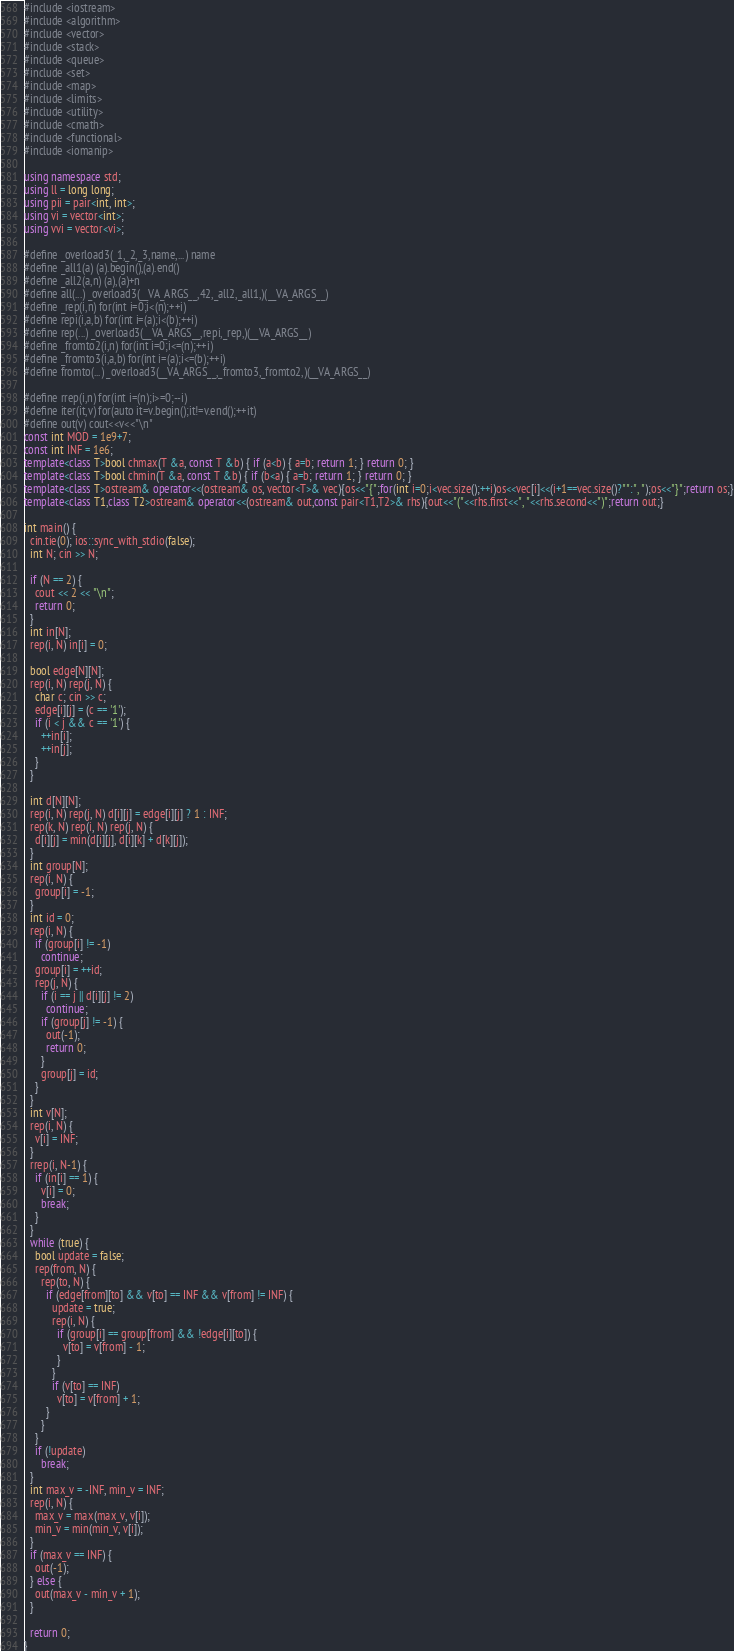<code> <loc_0><loc_0><loc_500><loc_500><_C++_>#include <iostream>
#include <algorithm>
#include <vector>
#include <stack>
#include <queue>
#include <set>
#include <map>
#include <limits>
#include <utility>
#include <cmath>
#include <functional>
#include <iomanip>

using namespace std;
using ll = long long;
using pii = pair<int, int>;
using vi = vector<int>;
using vvi = vector<vi>;

#define _overload3(_1,_2,_3,name,...) name
#define _all1(a) (a).begin(),(a).end()
#define _all2(a,n) (a),(a)+n
#define all(...) _overload3(__VA_ARGS__,42,_all2,_all1,)(__VA_ARGS__)
#define _rep(i,n) for(int i=0;i<(n);++i)
#define repi(i,a,b) for(int i=(a);i<(b);++i)
#define rep(...) _overload3(__VA_ARGS__,repi,_rep,)(__VA_ARGS__)
#define _fromto2(i,n) for(int i=0;i<=(n);++i)
#define _fromto3(i,a,b) for(int i=(a);i<=(b);++i)
#define fromto(...) _overload3(__VA_ARGS__,_fromto3,_fromto2,)(__VA_ARGS__)

#define rrep(i,n) for(int i=(n);i>=0;--i)
#define iter(it,v) for(auto it=v.begin();it!=v.end();++it)
#define out(v) cout<<v<<"\n"
const int MOD = 1e9+7;
const int INF = 1e6;
template<class T>bool chmax(T &a, const T &b) { if (a<b) { a=b; return 1; } return 0; }
template<class T>bool chmin(T &a, const T &b) { if (b<a) { a=b; return 1; } return 0; }
template<class T>ostream& operator<<(ostream& os, vector<T>& vec){os<<"{";for(int i=0;i<vec.size();++i)os<<vec[i]<<(i+1==vec.size()?"":", ");os<<"}";return os;}
template<class T1,class T2>ostream& operator<<(ostream& out,const pair<T1,T2>& rhs){out<<"("<<rhs.first<<", "<<rhs.second<<")";return out;}

int main() {
  cin.tie(0); ios::sync_with_stdio(false);
  int N; cin >> N;

  if (N == 2) {
    cout << 2 << "\n";
    return 0;
  }
  int in[N];
  rep(i, N) in[i] = 0;

  bool edge[N][N];
  rep(i, N) rep(j, N) {
    char c; cin >> c;
    edge[i][j] = (c == '1');
    if (i < j && c == '1') {
      ++in[i];
      ++in[j];
    }
  }

  int d[N][N];
  rep(i, N) rep(j, N) d[i][j] = edge[i][j] ? 1 : INF;
  rep(k, N) rep(i, N) rep(j, N) {
    d[i][j] = min(d[i][j], d[i][k] + d[k][j]);
  }
  int group[N];
  rep(i, N) {
    group[i] = -1;
  }
  int id = 0;
  rep(i, N) {
    if (group[i] != -1)
      continue;
    group[i] = ++id;
    rep(j, N) {
      if (i == j || d[i][j] != 2)
        continue;
      if (group[j] != -1) {
        out(-1);
        return 0;
      }
      group[j] = id;
    }
  }
  int v[N];
  rep(i, N) {
    v[i] = INF;
  }
  rrep(i, N-1) {
    if (in[i] == 1) {
      v[i] = 0;
      break;
    }
  }
  while (true) {
    bool update = false;
    rep(from, N) {
      rep(to, N) {
        if (edge[from][to] && v[to] == INF && v[from] != INF) {
          update = true;
          rep(i, N) {
            if (group[i] == group[from] && !edge[i][to]) {
              v[to] = v[from] - 1;
            }
          }
          if (v[to] == INF)
            v[to] = v[from] + 1;
        }
      }
    }
    if (!update)
      break;
  }
  int max_v = -INF, min_v = INF;
  rep(i, N) {
    max_v = max(max_v, v[i]);
    min_v = min(min_v, v[i]);
  }
  if (max_v == INF) {
    out(-1);
  } else {
    out(max_v - min_v + 1);
  }

  return 0;
}
</code> 